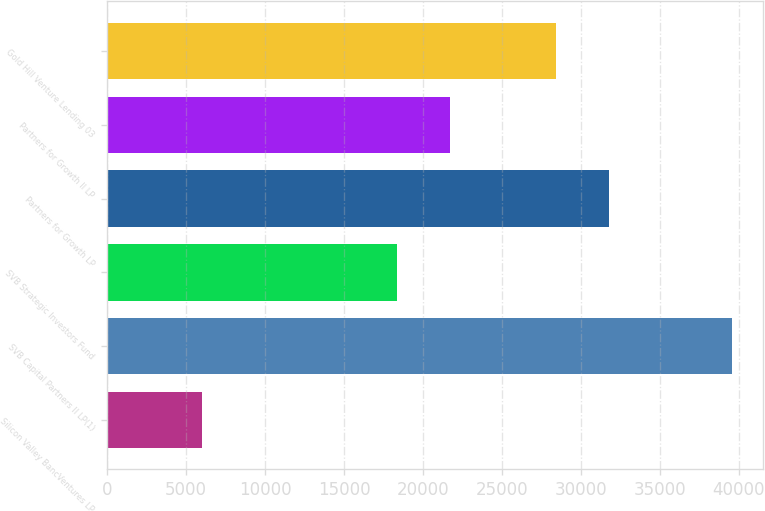Convert chart to OTSL. <chart><loc_0><loc_0><loc_500><loc_500><bar_chart><fcel>Silicon Valley BancVentures LP<fcel>SVB Capital Partners II LP(1)<fcel>SVB Strategic Investors Fund<fcel>Partners for Growth LP<fcel>Partners for Growth II LP<fcel>Gold Hill Venture Lending 03<nl><fcel>6000<fcel>39575<fcel>18357.5<fcel>31787.5<fcel>21715<fcel>28430<nl></chart> 